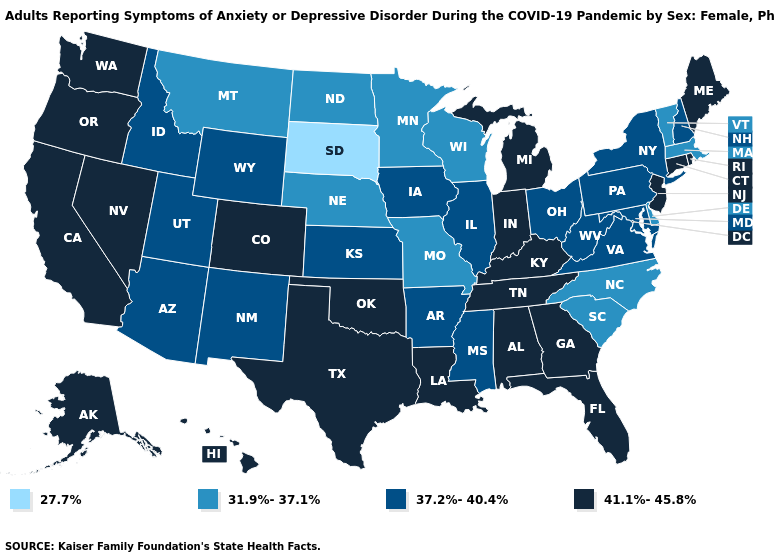Does Maine have the lowest value in the Northeast?
Be succinct. No. What is the value of Vermont?
Keep it brief. 31.9%-37.1%. What is the value of Vermont?
Give a very brief answer. 31.9%-37.1%. Is the legend a continuous bar?
Write a very short answer. No. Among the states that border Nevada , which have the highest value?
Answer briefly. California, Oregon. Which states have the highest value in the USA?
Keep it brief. Alabama, Alaska, California, Colorado, Connecticut, Florida, Georgia, Hawaii, Indiana, Kentucky, Louisiana, Maine, Michigan, Nevada, New Jersey, Oklahoma, Oregon, Rhode Island, Tennessee, Texas, Washington. What is the value of New Hampshire?
Give a very brief answer. 37.2%-40.4%. Name the states that have a value in the range 27.7%?
Short answer required. South Dakota. How many symbols are there in the legend?
Concise answer only. 4. Which states hav the highest value in the West?
Give a very brief answer. Alaska, California, Colorado, Hawaii, Nevada, Oregon, Washington. How many symbols are there in the legend?
Concise answer only. 4. Name the states that have a value in the range 27.7%?
Give a very brief answer. South Dakota. What is the value of New Jersey?
Quick response, please. 41.1%-45.8%. Does the first symbol in the legend represent the smallest category?
Short answer required. Yes. Name the states that have a value in the range 27.7%?
Concise answer only. South Dakota. 